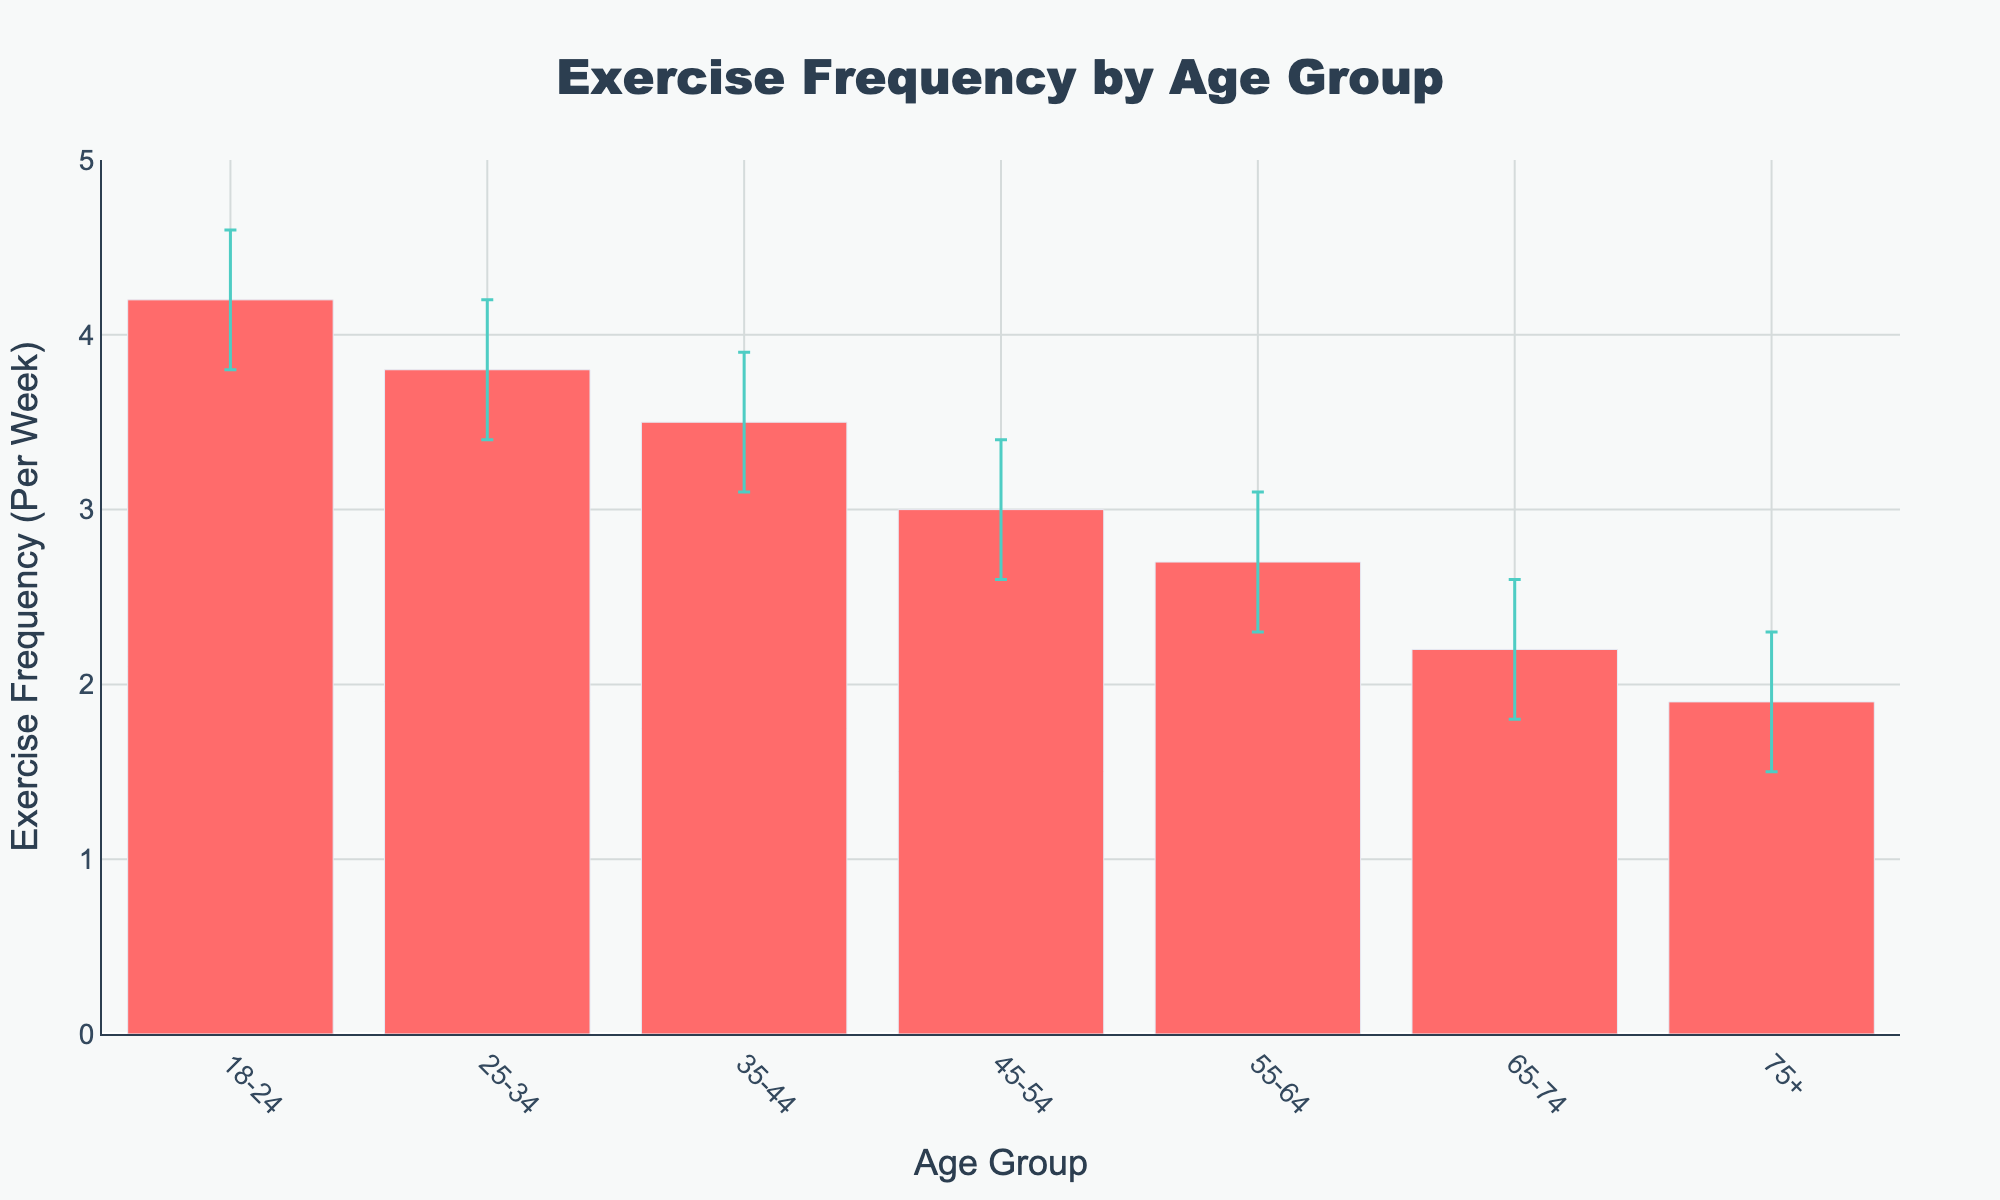What is the title of the chart? The title of the chart is prominently displayed at the top and states, "Exercise Frequency by Age Group".
Answer: Exercise Frequency by Age Group What is the y-axis title? The y-axis title, located along the vertical axis, is "Exercise Frequency (Per Week)".
Answer: Exercise Frequency (Per Week) How many age groups are represented in the chart? The x-axis shows a distinct label for each age group. Counting these labels, we get seven age groups.
Answer: Seven Which age group has the highest exercise frequency per week? By looking at the height of the bars, the first bar representing the 18-24 age group is the tallest, indicating it has the highest exercise frequency per week.
Answer: 18-24 What is the exercise frequency per week for the 45-54 age group? The bar corresponding to the 45-54 age group reaches up to the y-axis value of 3.0.
Answer: 3.0 How much lower is the exercise frequency for the 55-64 age group compared to the 35-44 age group? The exercise frequency for 55-64 is 2.7, and for 35-44 it is 3.5. The difference is calculated by subtracting 2.7 from 3.5.
Answer: 0.8 What are the confidence intervals for the 75+ age group? The bar for the 75+ age group includes error bars extending from 1.5 to 2.3, indicating the confidence interval's lower and upper bounds respectively.
Answer: 1.5 to 2.3 Which age group has the smallest confidence interval range? Examining the lengths of the error bars, the 35-44 age group's error bars are the shortest, indicating the smallest confidence interval range of 0.8 (3.9 - 3.1).
Answer: 35-44 How does the 25-34 age group's exercise frequency compare to the 45-54 age group? The exercise frequency for 25-34 is 3.8, and for 45-54 it is 3.0. Therefore, the 25-34 age group exercises more frequently by 0.8 times per week.
Answer: 25-34 exercises more by 0.8 Which age group has the highest confidence interval upper bound? The highest point of the error bars is seen in the 18-24 age group, reaching up to 4.6.
Answer: 18-24 